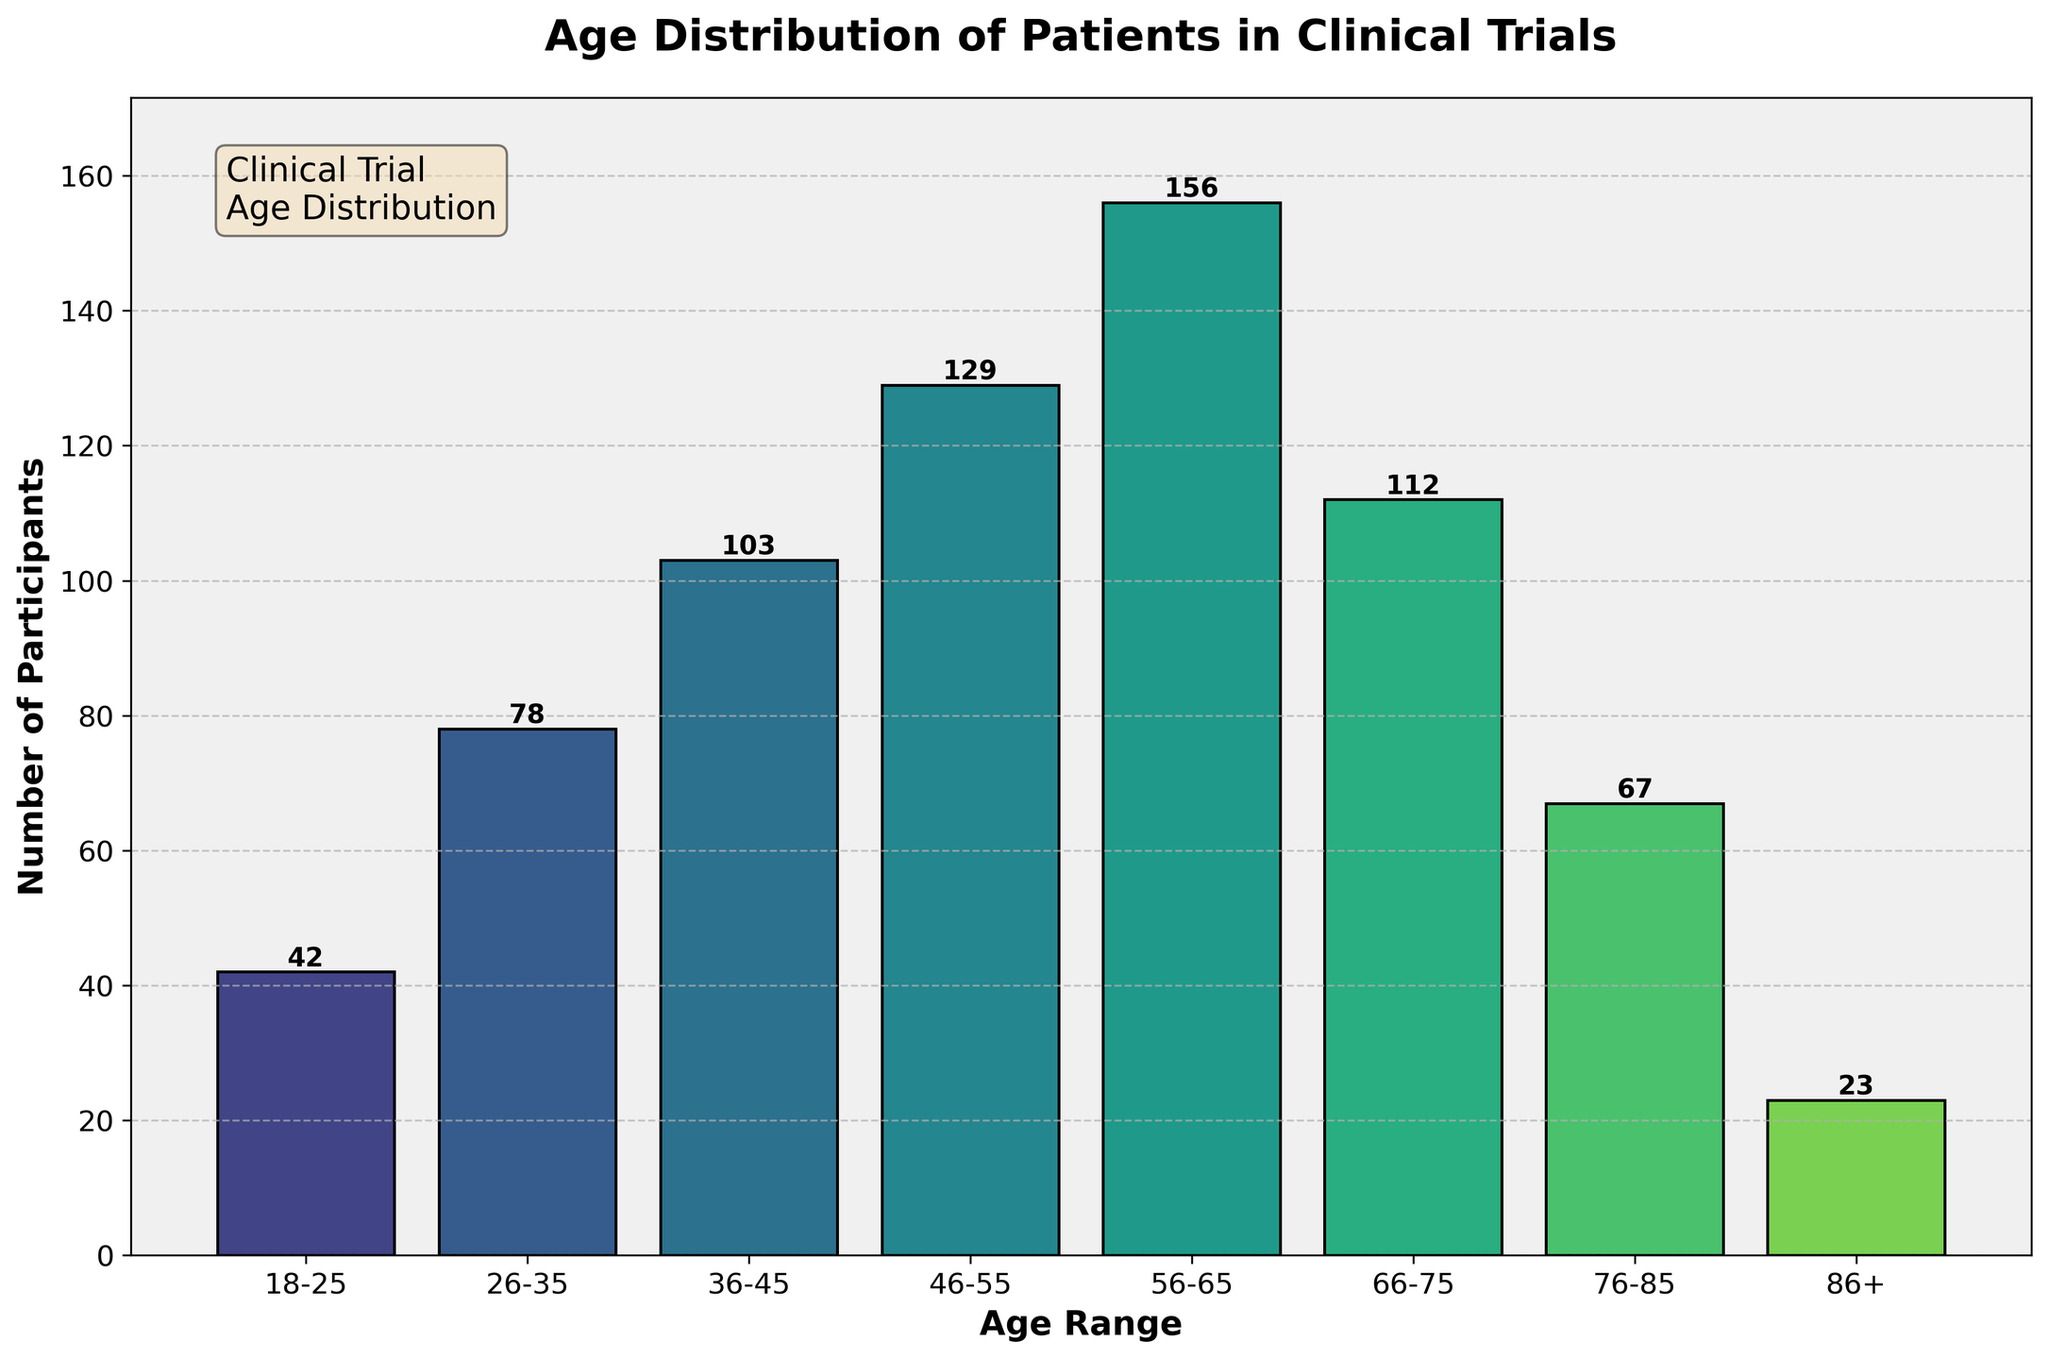What's the title of the plot? The title of the plot is displayed at the top center. It reads "Age Distribution of Patients in Clinical Trials".
Answer: Age Distribution of Patients in Clinical Trials What does the y-axis represent? The y-axis is labeled as "Number of Participants". This indicates that the y-axis shows the number of patients in each age range.
Answer: Number of Participants In which age range is the highest number of participants? By observing the heights of the bars, the age range 56-65 has the highest bar, indicating the largest number of participants.
Answer: 56-65 How many participants are in the 46-55 age range? The bar for the age range 46-55 has a label on top indicating the number of participants, which is 129.
Answer: 129 Which age range has the fewest participants? The bar for the age range 86+ is the shortest, indicating the smallest number of participants, which is 23.
Answer: 86+ What is the combined number of participants in the age ranges 26-35 and 36-45? Summing the number of participants in the age ranges 26-35 and 36-45 gives: 78 (26-35) + 103 (36-45) = 181.
Answer: 181 Are there more participants in the age range 76-85 or 18-25? Comparing the bars for the age ranges 76-85 and 18-25, there are more participants in the age range 76-85 (67) than in 18-25 (42).
Answer: 76-85 What is the total number of participants in all the age ranges combined? Summing the number of participants across all age ranges gives: 42 (18-25) + 78 (26-35) + 103 (36-45) + 129 (46-55) + 156 (56-65) + 112 (66-75) + 67 (76-85) + 23 (86+) = 710.
Answer: 710 By how many participants does the age range 56-65 exceed the age range 46-55? Subtracting the number of participants in the age range 46-55 (129) from the number of participants in 56-65 (156) gives: 156 - 129 = 27.
Answer: 27 